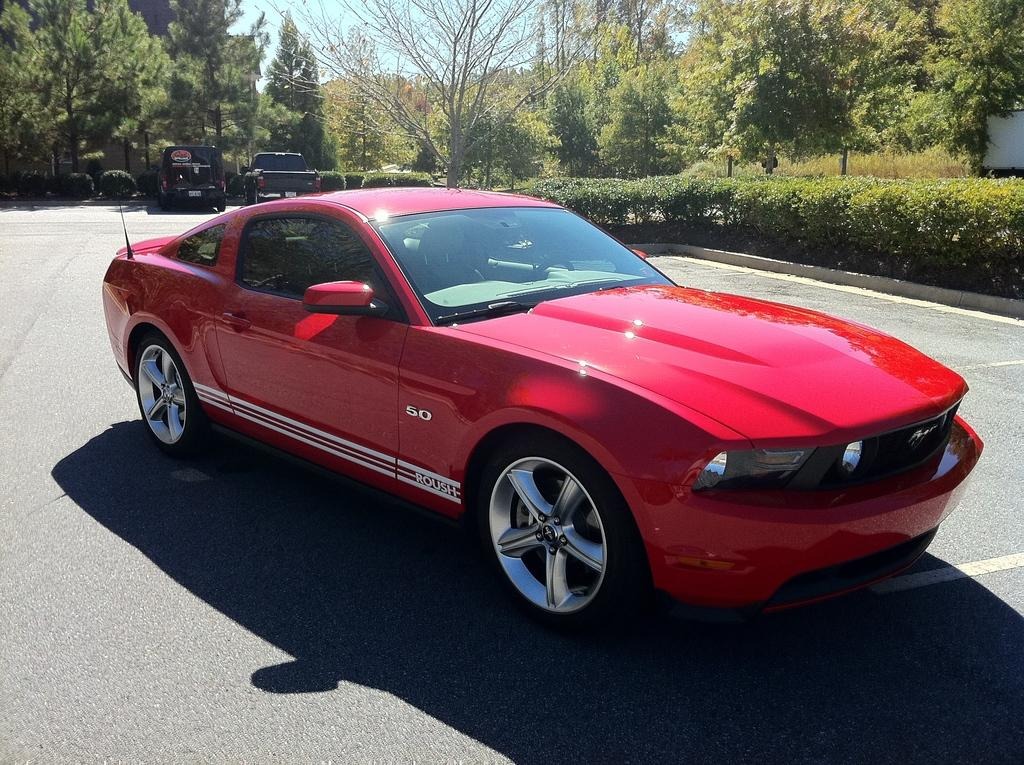What can be seen on the road in the image? There are vehicles on the road in the image. What type of natural elements are present in the image? There are plants, trees, and the sky visible in the image. What man-made structures can be seen in the image? There are poles in the image. Can you describe the object on the right side of the image? Unfortunately, the facts provided do not give enough information to describe the object on the right side of the image. What type of notebook is the secretary using in the image? There is no secretary or notebook present in the image. Can you tell me how many clams are visible in the image? There are no clams present in the image. 